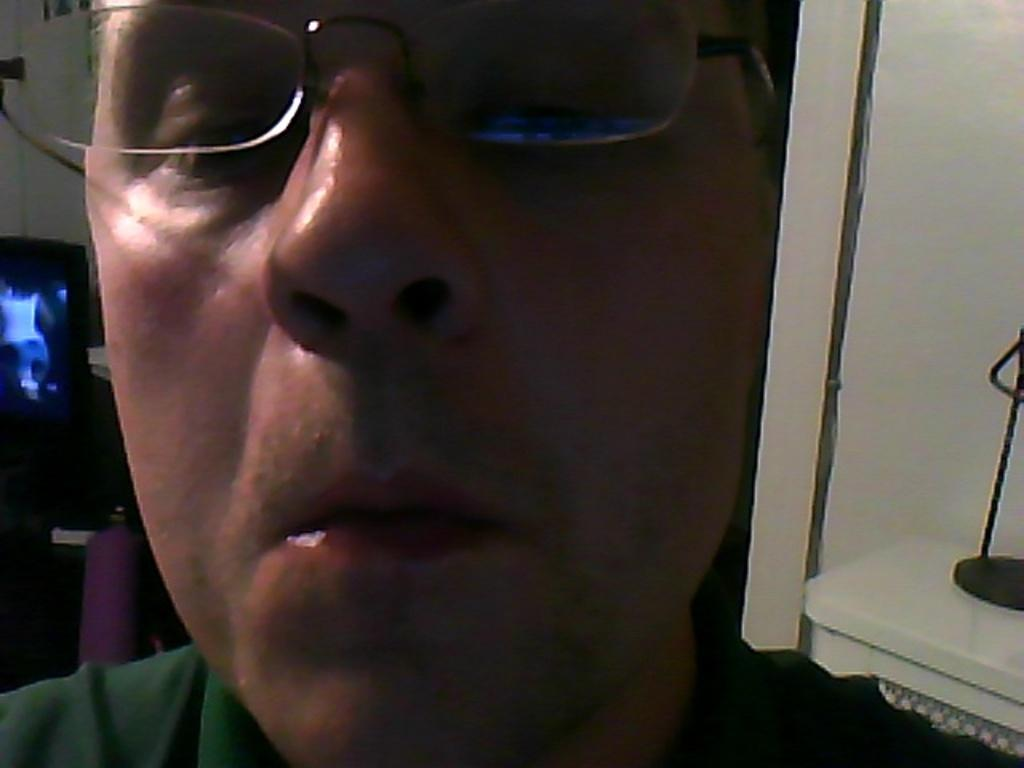Who or what is the main subject in the image? There is a person in the image. What can be observed about the person's appearance? The person is wearing spectacles. What type of object is visible behind the person? There is a metal object visible behind the person. How many eggs are being held by the person's brother in the image? There is no brother present in the image, and therefore no one is holding any eggs. 